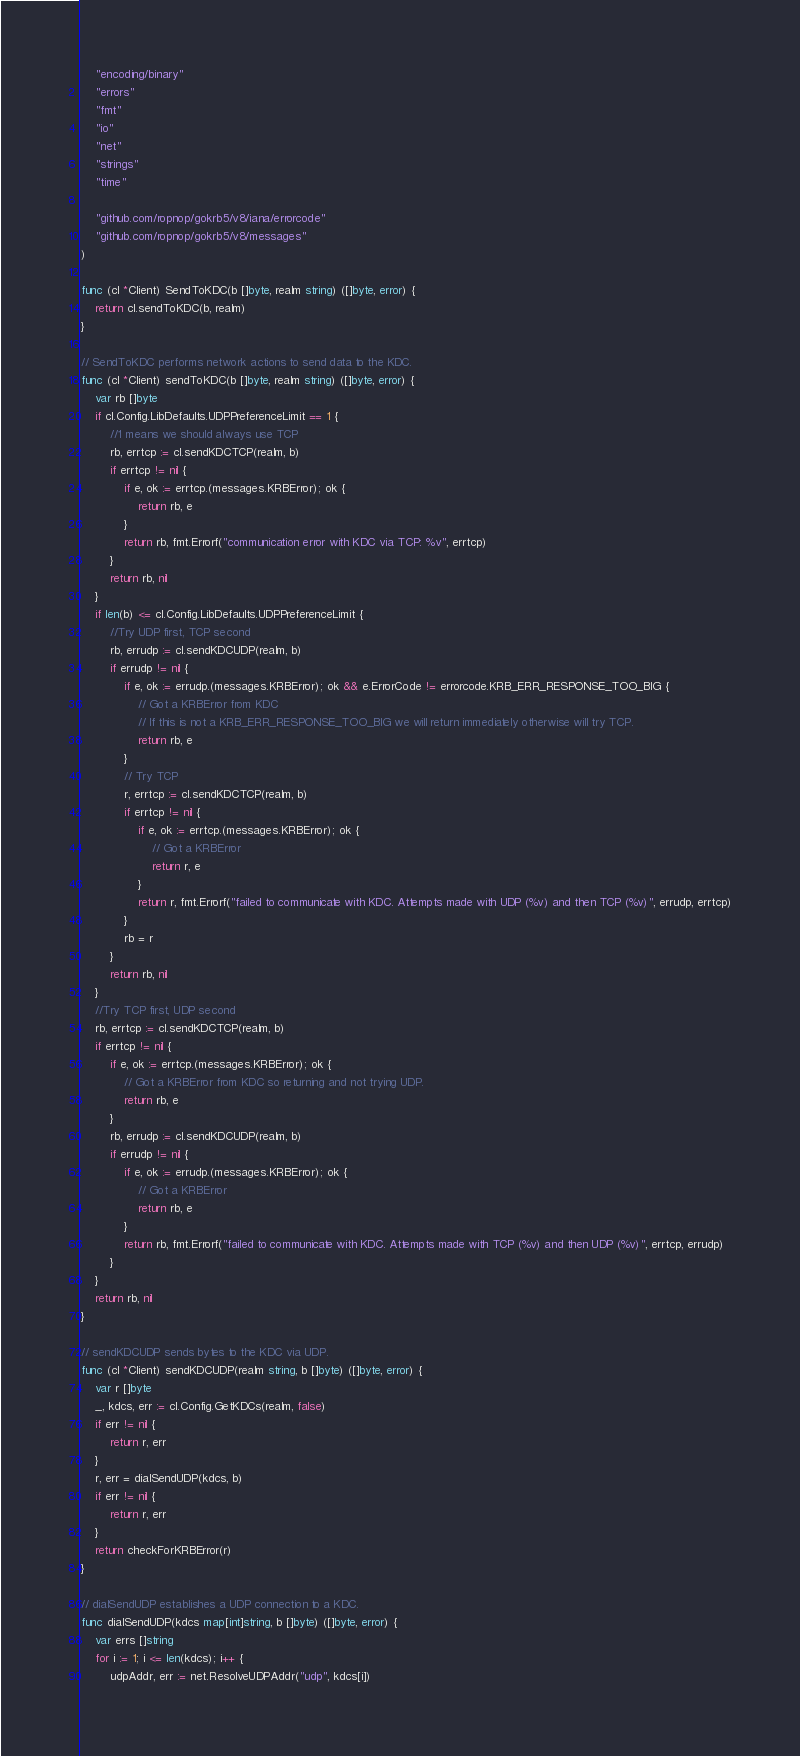Convert code to text. <code><loc_0><loc_0><loc_500><loc_500><_Go_>	"encoding/binary"
	"errors"
	"fmt"
	"io"
	"net"
	"strings"
	"time"

	"github.com/ropnop/gokrb5/v8/iana/errorcode"
	"github.com/ropnop/gokrb5/v8/messages"
)

func (cl *Client) SendToKDC(b []byte, realm string) ([]byte, error) {
	return cl.sendToKDC(b, realm)
}

// SendToKDC performs network actions to send data to the KDC.
func (cl *Client) sendToKDC(b []byte, realm string) ([]byte, error) {
	var rb []byte
	if cl.Config.LibDefaults.UDPPreferenceLimit == 1 {
		//1 means we should always use TCP
		rb, errtcp := cl.sendKDCTCP(realm, b)
		if errtcp != nil {
			if e, ok := errtcp.(messages.KRBError); ok {
				return rb, e
			}
			return rb, fmt.Errorf("communication error with KDC via TCP: %v", errtcp)
		}
		return rb, nil
	}
	if len(b) <= cl.Config.LibDefaults.UDPPreferenceLimit {
		//Try UDP first, TCP second
		rb, errudp := cl.sendKDCUDP(realm, b)
		if errudp != nil {
			if e, ok := errudp.(messages.KRBError); ok && e.ErrorCode != errorcode.KRB_ERR_RESPONSE_TOO_BIG {
				// Got a KRBError from KDC
				// If this is not a KRB_ERR_RESPONSE_TOO_BIG we will return immediately otherwise will try TCP.
				return rb, e
			}
			// Try TCP
			r, errtcp := cl.sendKDCTCP(realm, b)
			if errtcp != nil {
				if e, ok := errtcp.(messages.KRBError); ok {
					// Got a KRBError
					return r, e
				}
				return r, fmt.Errorf("failed to communicate with KDC. Attempts made with UDP (%v) and then TCP (%v)", errudp, errtcp)
			}
			rb = r
		}
		return rb, nil
	}
	//Try TCP first, UDP second
	rb, errtcp := cl.sendKDCTCP(realm, b)
	if errtcp != nil {
		if e, ok := errtcp.(messages.KRBError); ok {
			// Got a KRBError from KDC so returning and not trying UDP.
			return rb, e
		}
		rb, errudp := cl.sendKDCUDP(realm, b)
		if errudp != nil {
			if e, ok := errudp.(messages.KRBError); ok {
				// Got a KRBError
				return rb, e
			}
			return rb, fmt.Errorf("failed to communicate with KDC. Attempts made with TCP (%v) and then UDP (%v)", errtcp, errudp)
		}
	}
	return rb, nil
}

// sendKDCUDP sends bytes to the KDC via UDP.
func (cl *Client) sendKDCUDP(realm string, b []byte) ([]byte, error) {
	var r []byte
	_, kdcs, err := cl.Config.GetKDCs(realm, false)
	if err != nil {
		return r, err
	}
	r, err = dialSendUDP(kdcs, b)
	if err != nil {
		return r, err
	}
	return checkForKRBError(r)
}

// dialSendUDP establishes a UDP connection to a KDC.
func dialSendUDP(kdcs map[int]string, b []byte) ([]byte, error) {
	var errs []string
	for i := 1; i <= len(kdcs); i++ {
		udpAddr, err := net.ResolveUDPAddr("udp", kdcs[i])</code> 